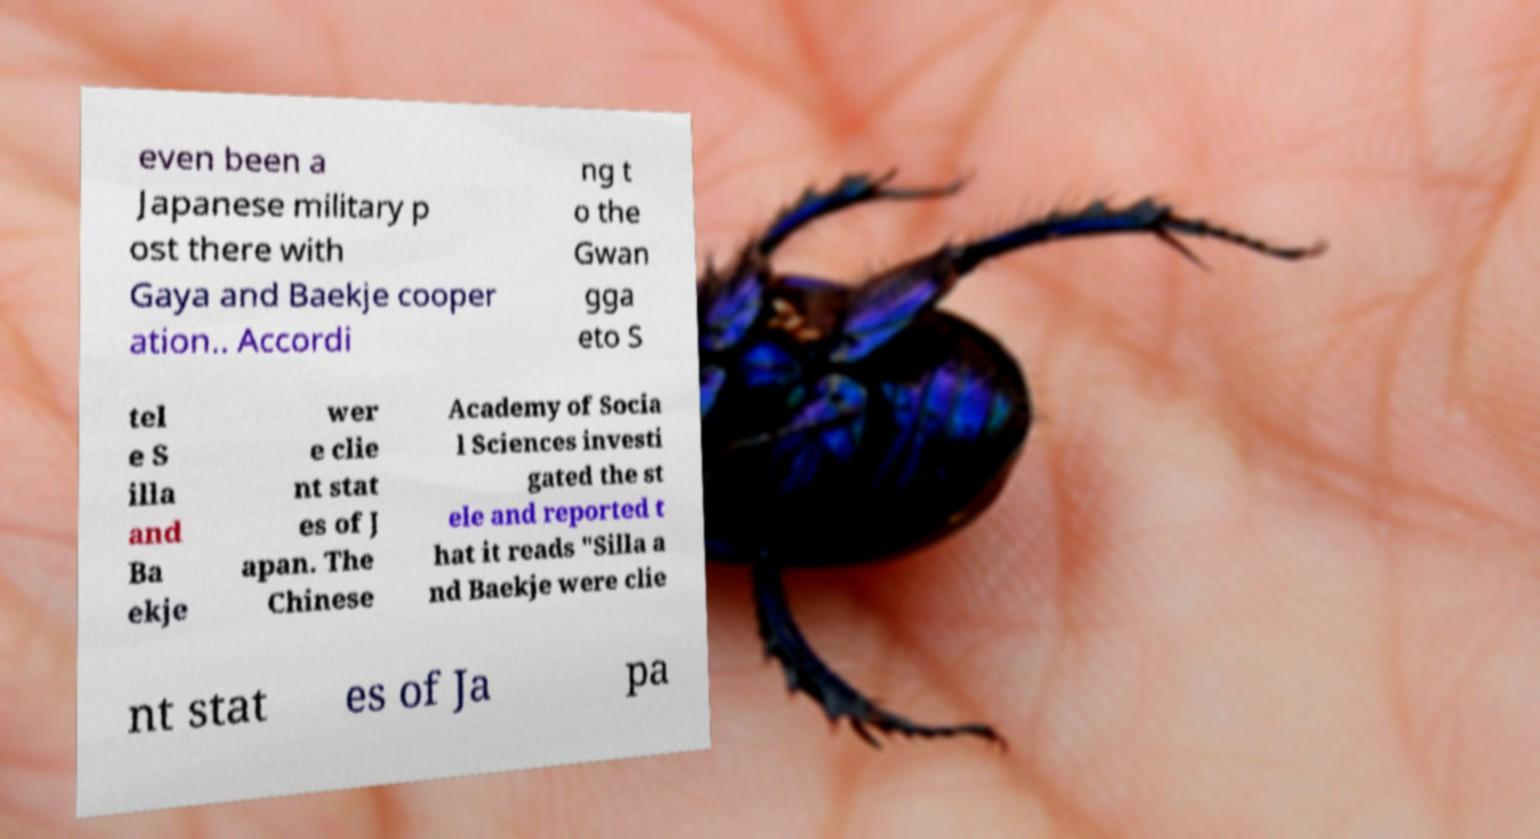I need the written content from this picture converted into text. Can you do that? even been a Japanese military p ost there with Gaya and Baekje cooper ation.. Accordi ng t o the Gwan gga eto S tel e S illa and Ba ekje wer e clie nt stat es of J apan. The Chinese Academy of Socia l Sciences investi gated the st ele and reported t hat it reads "Silla a nd Baekje were clie nt stat es of Ja pa 